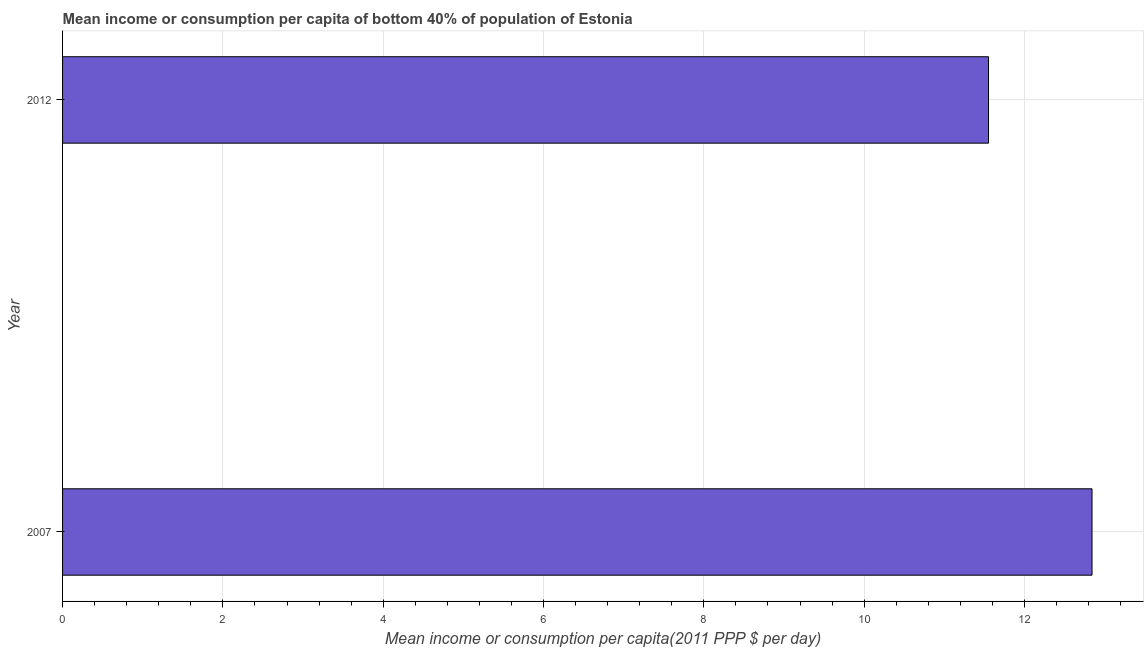Does the graph contain grids?
Your answer should be very brief. Yes. What is the title of the graph?
Your answer should be compact. Mean income or consumption per capita of bottom 40% of population of Estonia. What is the label or title of the X-axis?
Provide a short and direct response. Mean income or consumption per capita(2011 PPP $ per day). What is the mean income or consumption in 2007?
Make the answer very short. 12.84. Across all years, what is the maximum mean income or consumption?
Your answer should be compact. 12.84. Across all years, what is the minimum mean income or consumption?
Give a very brief answer. 11.55. What is the sum of the mean income or consumption?
Provide a succinct answer. 24.39. What is the difference between the mean income or consumption in 2007 and 2012?
Give a very brief answer. 1.29. What is the average mean income or consumption per year?
Give a very brief answer. 12.2. What is the median mean income or consumption?
Make the answer very short. 12.2. In how many years, is the mean income or consumption greater than 2.4 $?
Your answer should be very brief. 2. What is the ratio of the mean income or consumption in 2007 to that in 2012?
Provide a succinct answer. 1.11. Is the mean income or consumption in 2007 less than that in 2012?
Provide a succinct answer. No. In how many years, is the mean income or consumption greater than the average mean income or consumption taken over all years?
Keep it short and to the point. 1. How many bars are there?
Ensure brevity in your answer.  2. Are all the bars in the graph horizontal?
Your response must be concise. Yes. Are the values on the major ticks of X-axis written in scientific E-notation?
Your answer should be very brief. No. What is the Mean income or consumption per capita(2011 PPP $ per day) in 2007?
Provide a succinct answer. 12.84. What is the Mean income or consumption per capita(2011 PPP $ per day) in 2012?
Give a very brief answer. 11.55. What is the difference between the Mean income or consumption per capita(2011 PPP $ per day) in 2007 and 2012?
Provide a short and direct response. 1.29. What is the ratio of the Mean income or consumption per capita(2011 PPP $ per day) in 2007 to that in 2012?
Your answer should be compact. 1.11. 